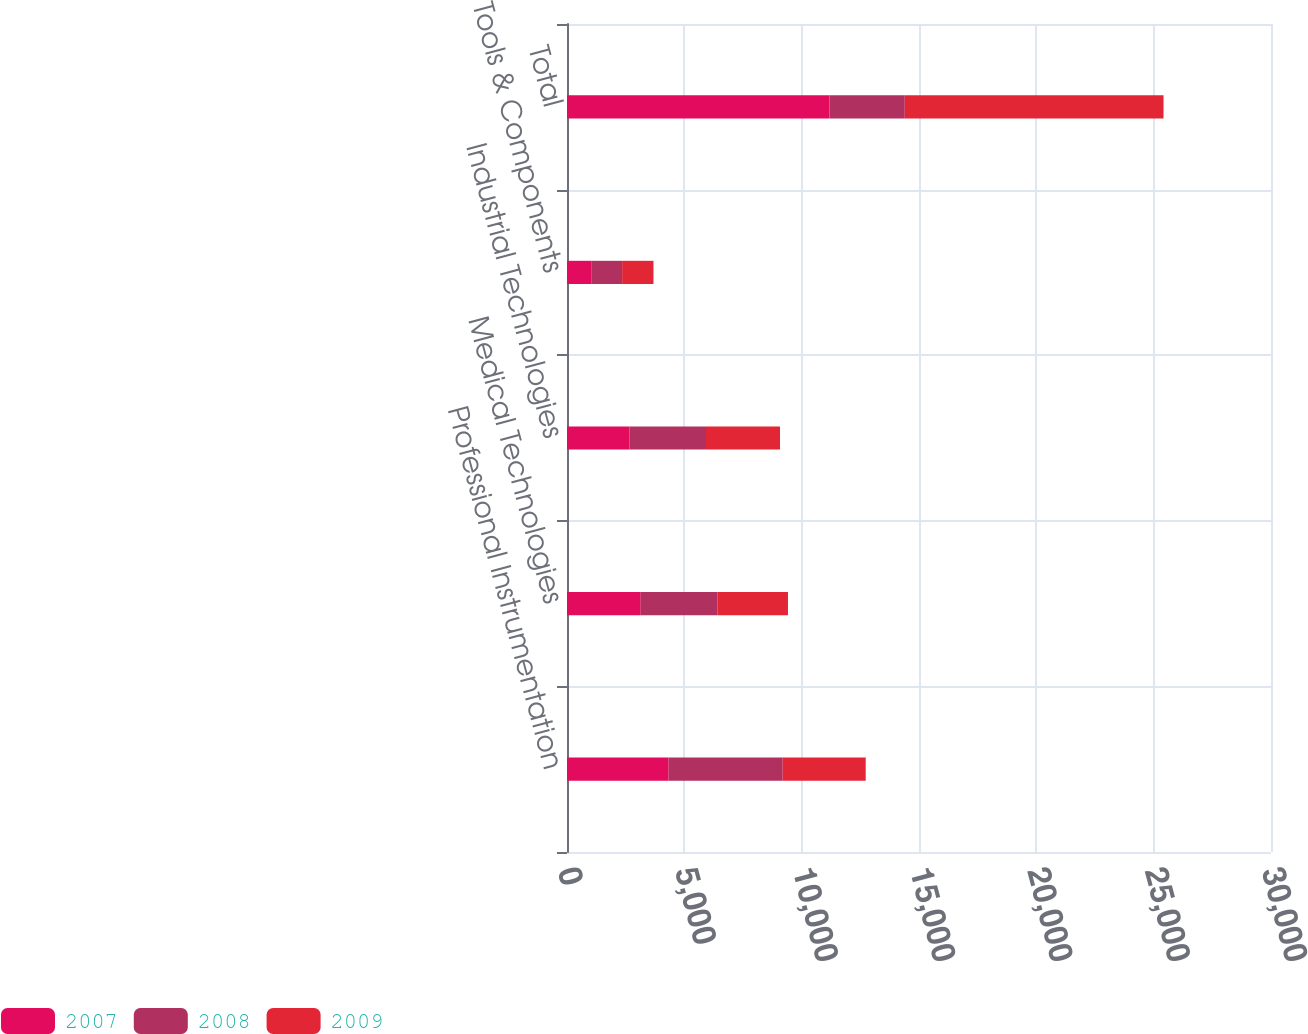Convert chart to OTSL. <chart><loc_0><loc_0><loc_500><loc_500><stacked_bar_chart><ecel><fcel>Professional Instrumentation<fcel>Medical Technologies<fcel>Industrial Technologies<fcel>Tools & Components<fcel>Total<nl><fcel>2007<fcel>4330.7<fcel>3141.9<fcel>2658<fcel>1054.3<fcel>11184.9<nl><fcel>2008<fcel>4860.8<fcel>3277<fcel>3265.5<fcel>1294.2<fcel>3209.45<nl><fcel>2009<fcel>3537.9<fcel>2998<fcel>3153.4<fcel>1336.6<fcel>11025.9<nl></chart> 